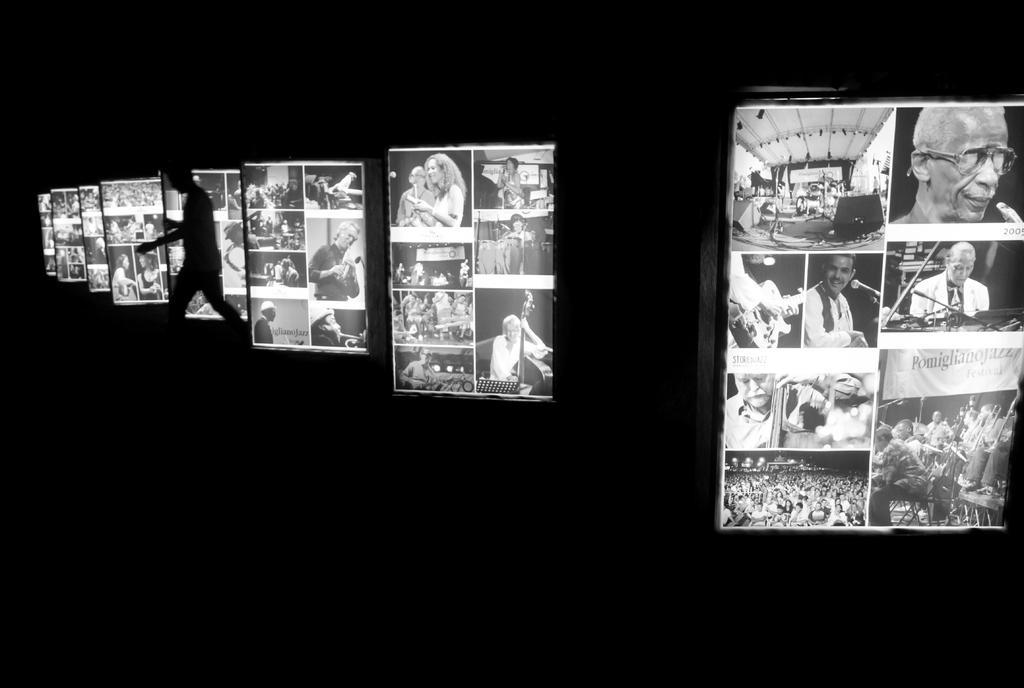Describe this image in one or two sentences. This is a black and white image and here we can see a person and there are boards with some people and some other objects. 